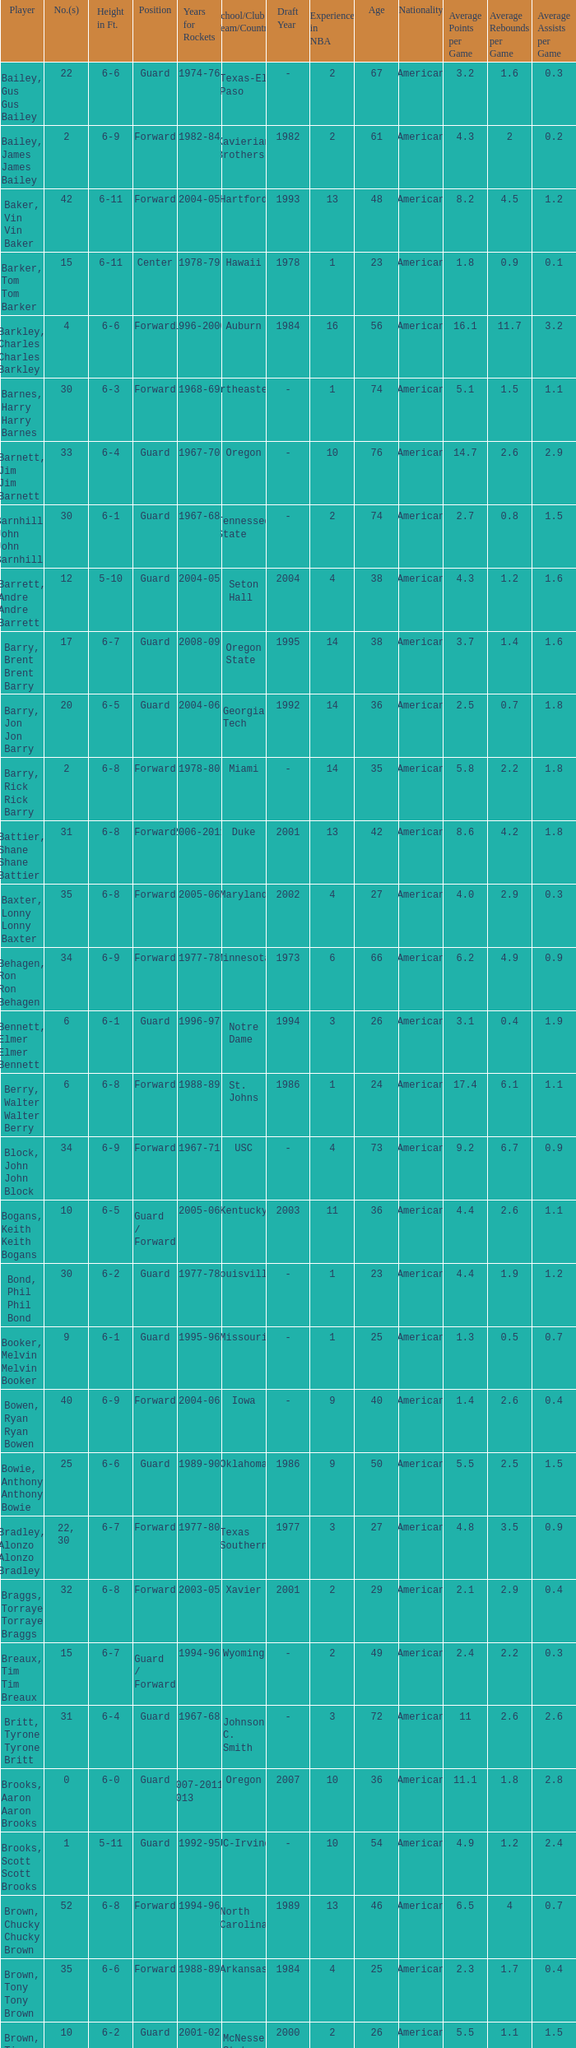What position is number 35 whose height is 6-6? Forward. 